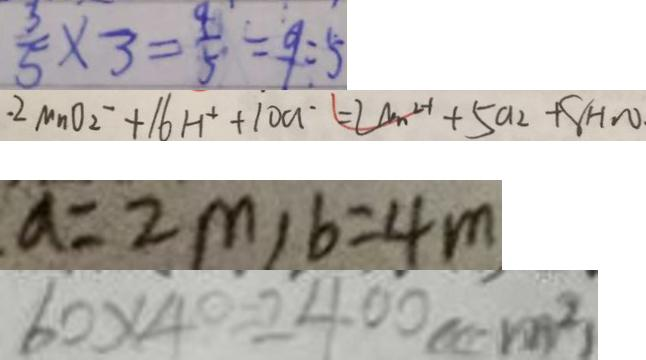Convert formula to latex. <formula><loc_0><loc_0><loc_500><loc_500>\frac { 3 } { 5 } \times 3 = \frac { 4 } { 5 } = 9 : 5 
 . 2 M n O _ { 2 ^ { - } } + 1 6 H ^ { + } + 1 0 a ^ { - } = 2 a _ { n } ^ { 2 - 1 } + 5 a _ { 2 } + 8 H _ { 2 } O . 
 a = 2 m , b = 4 m 
 6 0 \times 4 0 = 2 4 0 0 ( c m ^ { 2 } )</formula> 